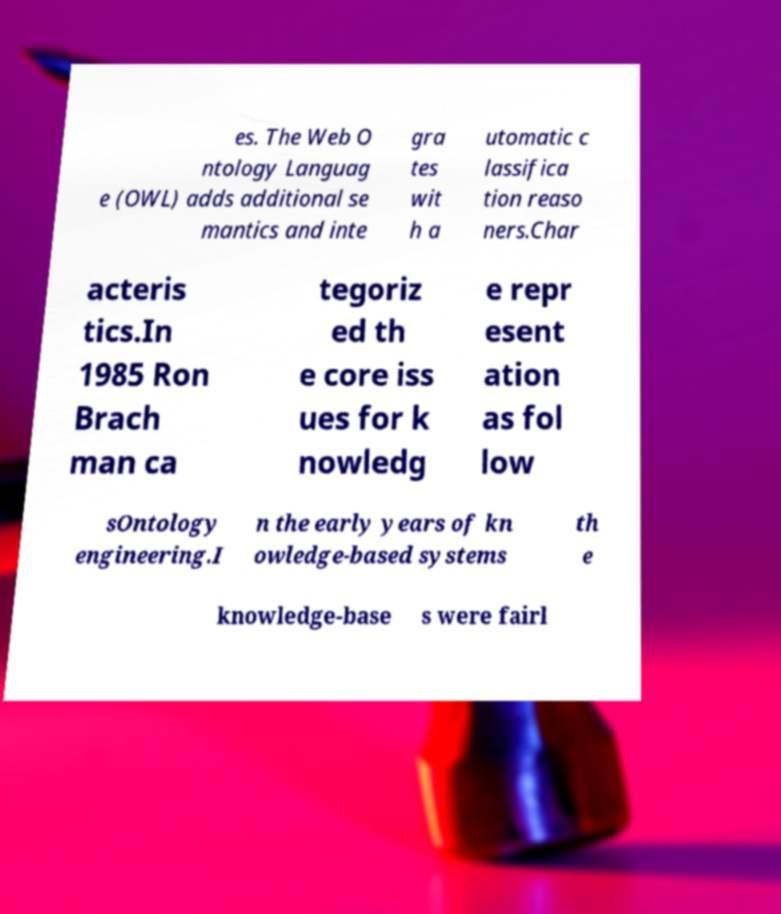Could you extract and type out the text from this image? es. The Web O ntology Languag e (OWL) adds additional se mantics and inte gra tes wit h a utomatic c lassifica tion reaso ners.Char acteris tics.In 1985 Ron Brach man ca tegoriz ed th e core iss ues for k nowledg e repr esent ation as fol low sOntology engineering.I n the early years of kn owledge-based systems th e knowledge-base s were fairl 